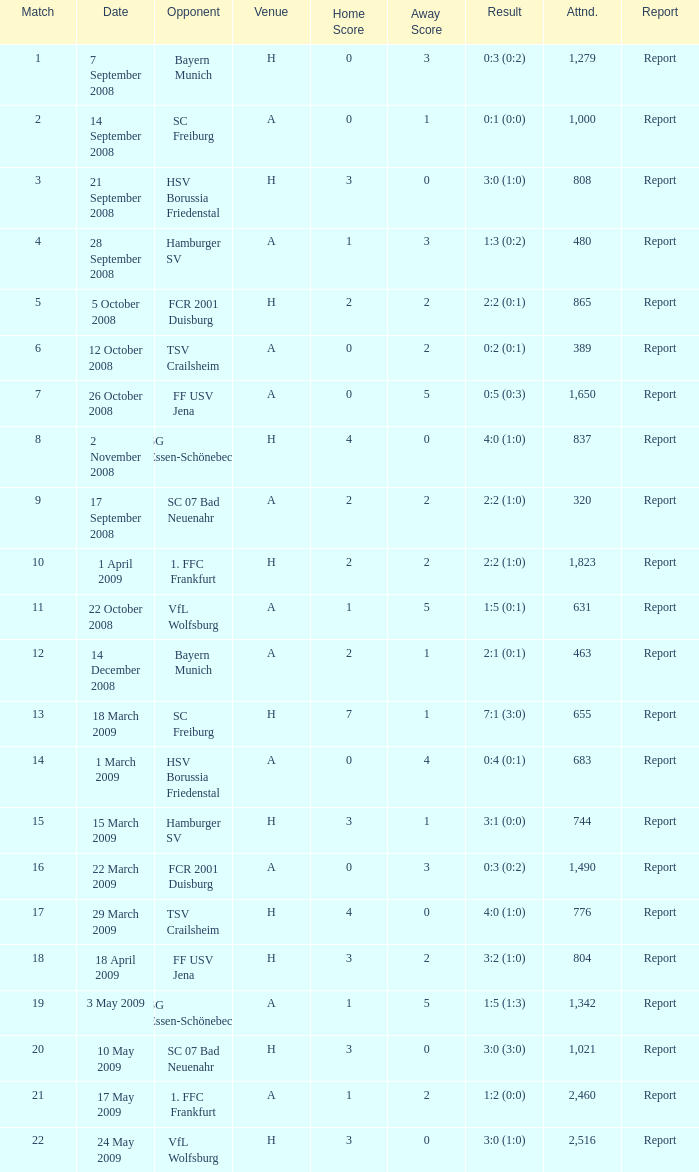Could you parse the entire table as a dict? {'header': ['Match', 'Date', 'Opponent', 'Venue', 'Home Score', 'Away Score', 'Result', 'Attnd.', 'Report'], 'rows': [['1', '7 September 2008', 'Bayern Munich', 'H', '0', '3', '0:3 (0:2)', '1,279', 'Report'], ['2', '14 September 2008', 'SC Freiburg', 'A', '0', '1', '0:1 (0:0)', '1,000', 'Report'], ['3', '21 September 2008', 'HSV Borussia Friedenstal', 'H', '3', '0', '3:0 (1:0)', '808', 'Report'], ['4', '28 September 2008', 'Hamburger SV', 'A', '1', '3', '1:3 (0:2)', '480', 'Report'], ['5', '5 October 2008', 'FCR 2001 Duisburg', 'H', '2', '2', '2:2 (0:1)', '865', 'Report'], ['6', '12 October 2008', 'TSV Crailsheim', 'A', '0', '2', '0:2 (0:1)', '389', 'Report'], ['7', '26 October 2008', 'FF USV Jena', 'A', '0', '5', '0:5 (0:3)', '1,650', 'Report'], ['8', '2 November 2008', 'SG Essen-Schönebeck', 'H', '4', '0', '4:0 (1:0)', '837', 'Report'], ['9', '17 September 2008', 'SC 07 Bad Neuenahr', 'A', '2', '2', '2:2 (1:0)', '320', 'Report'], ['10', '1 April 2009', '1. FFC Frankfurt', 'H', '2', '2', '2:2 (1:0)', '1,823', 'Report'], ['11', '22 October 2008', 'VfL Wolfsburg', 'A', '1', '5', '1:5 (0:1)', '631', 'Report'], ['12', '14 December 2008', 'Bayern Munich', 'A', '2', '1', '2:1 (0:1)', '463', 'Report'], ['13', '18 March 2009', 'SC Freiburg', 'H', '7', '1', '7:1 (3:0)', '655', 'Report'], ['14', '1 March 2009', 'HSV Borussia Friedenstal', 'A', '0', '4', '0:4 (0:1)', '683', 'Report'], ['15', '15 March 2009', 'Hamburger SV', 'H', '3', '1', '3:1 (0:0)', '744', 'Report'], ['16', '22 March 2009', 'FCR 2001 Duisburg', 'A', '0', '3', '0:3 (0:2)', '1,490', 'Report'], ['17', '29 March 2009', 'TSV Crailsheim', 'H', '4', '0', '4:0 (1:0)', '776', 'Report'], ['18', '18 April 2009', 'FF USV Jena', 'H', '3', '2', '3:2 (1:0)', '804', 'Report'], ['19', '3 May 2009', 'SG Essen-Schönebeck', 'A', '1', '5', '1:5 (1:3)', '1,342', 'Report'], ['20', '10 May 2009', 'SC 07 Bad Neuenahr', 'H', '3', '0', '3:0 (3:0)', '1,021', 'Report'], ['21', '17 May 2009', '1. FFC Frankfurt', 'A', '1', '2', '1:2 (0:0)', '2,460', 'Report'], ['22', '24 May 2009', 'VfL Wolfsburg', 'H', '3', '0', '3:0 (1:0)', '2,516', 'Report']]} Which match had more than 1,490 people in attendance to watch FCR 2001 Duisburg have a result of 0:3 (0:2)? None. 